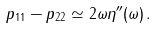<formula> <loc_0><loc_0><loc_500><loc_500>p _ { 1 1 } - p _ { 2 2 } \simeq 2 \omega \eta ^ { \prime \prime } ( \omega ) \, .</formula> 